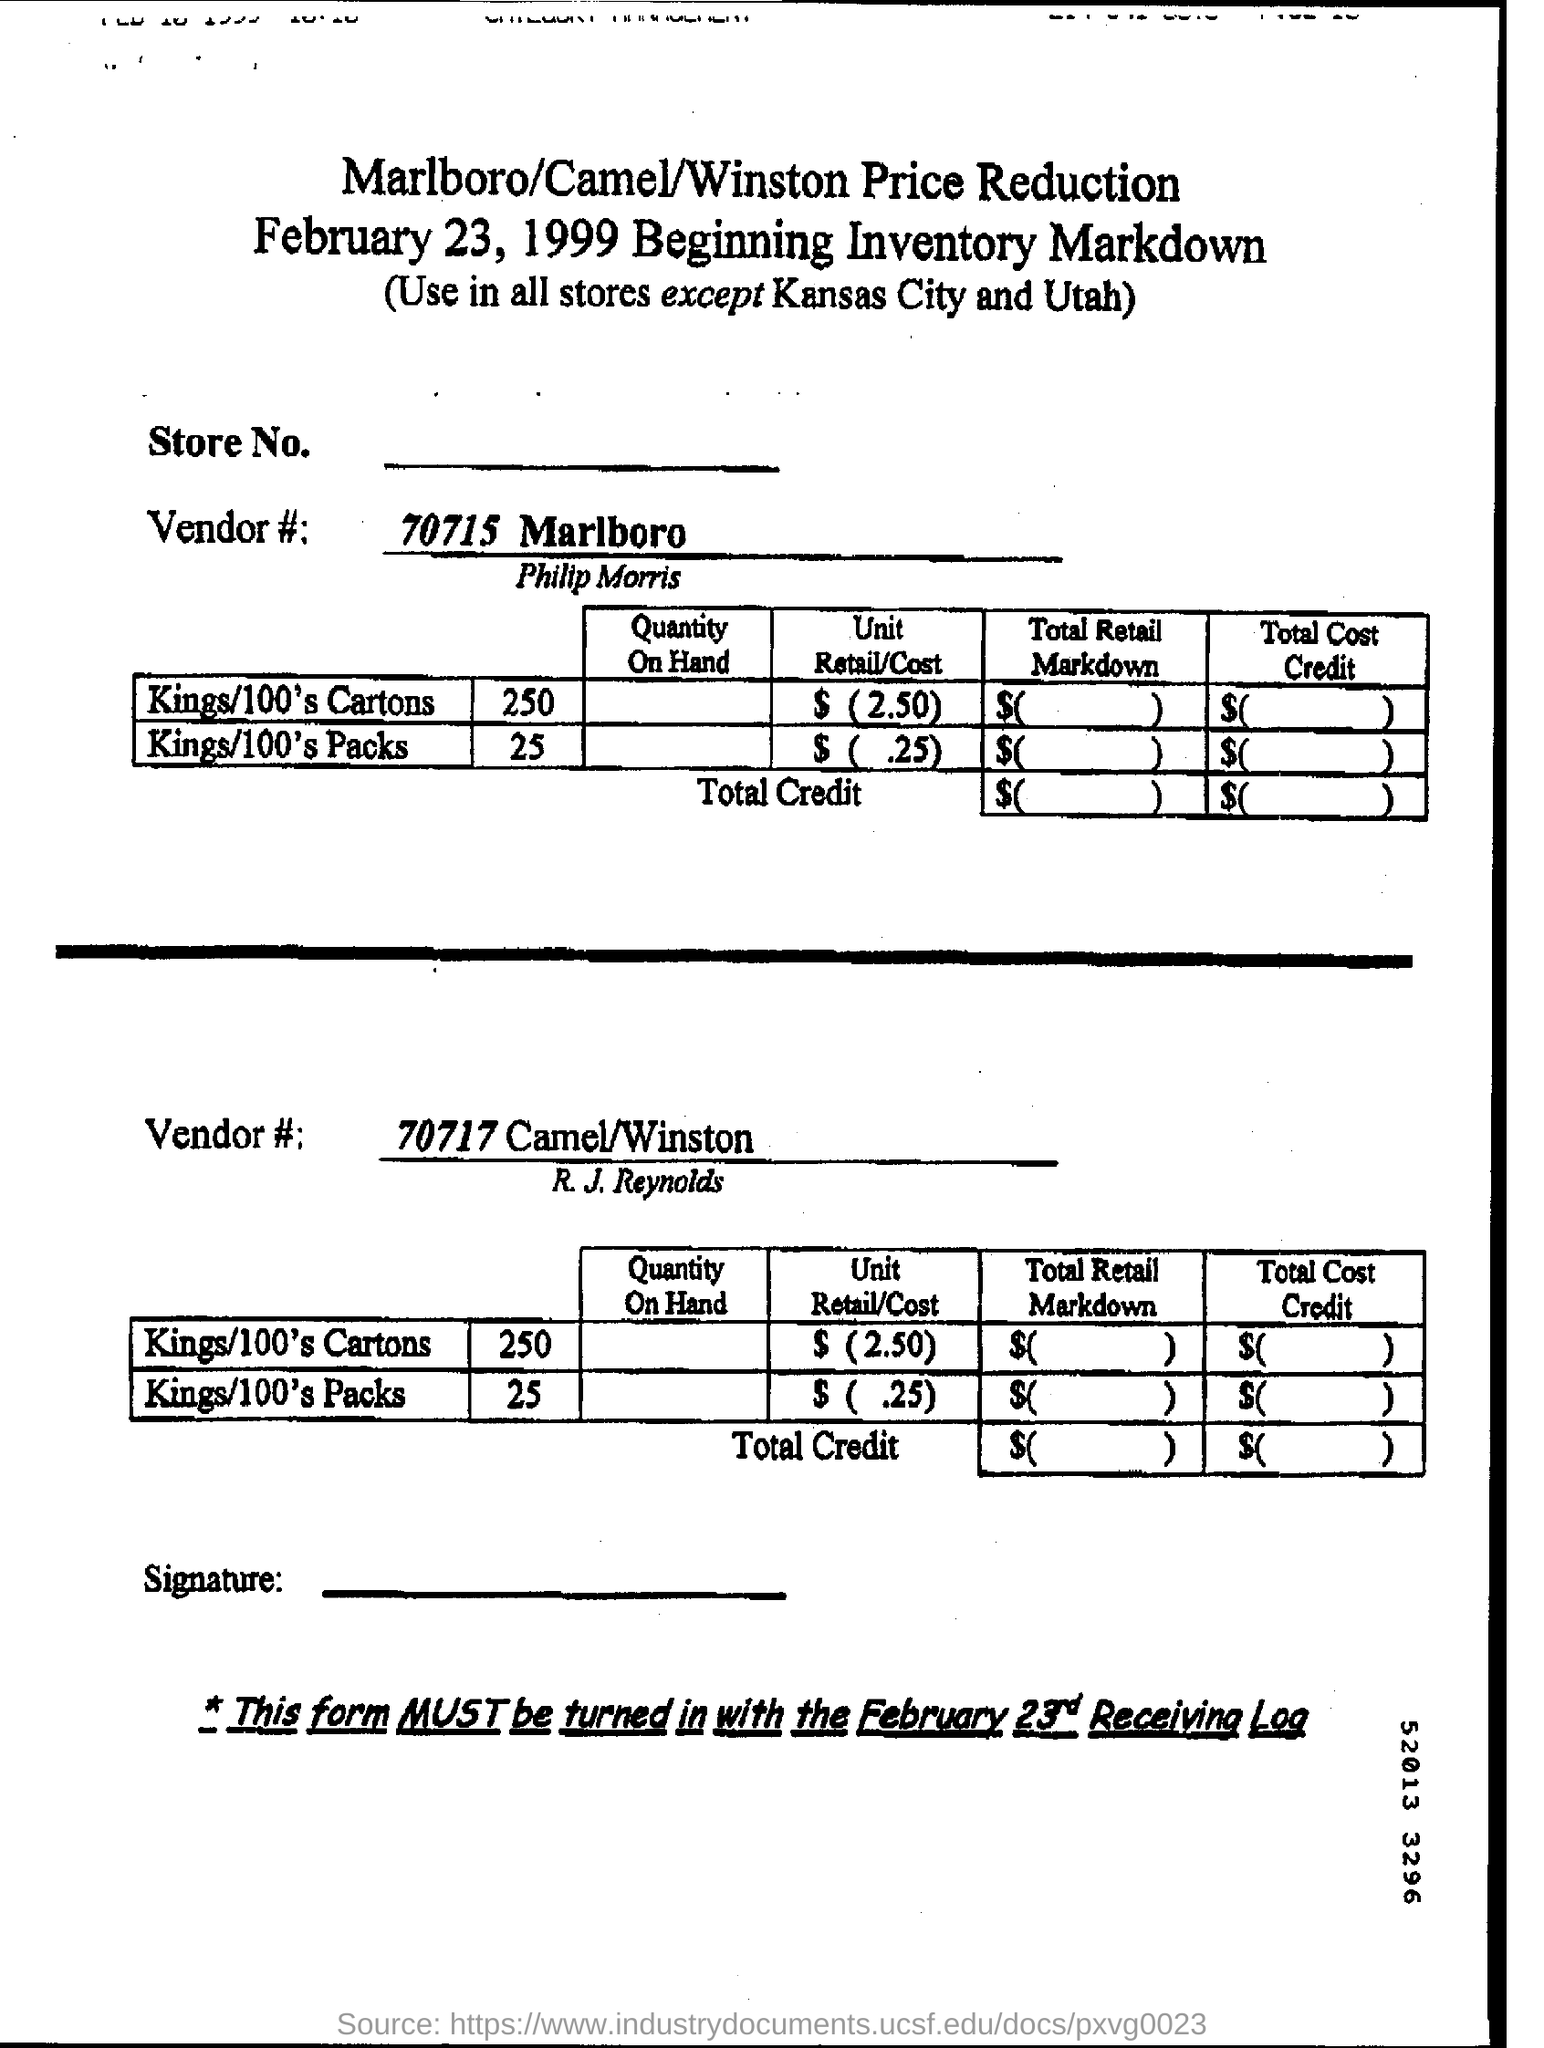When is the beginning inventory markdown form dated?
Your answer should be very brief. February 23, 1999. 